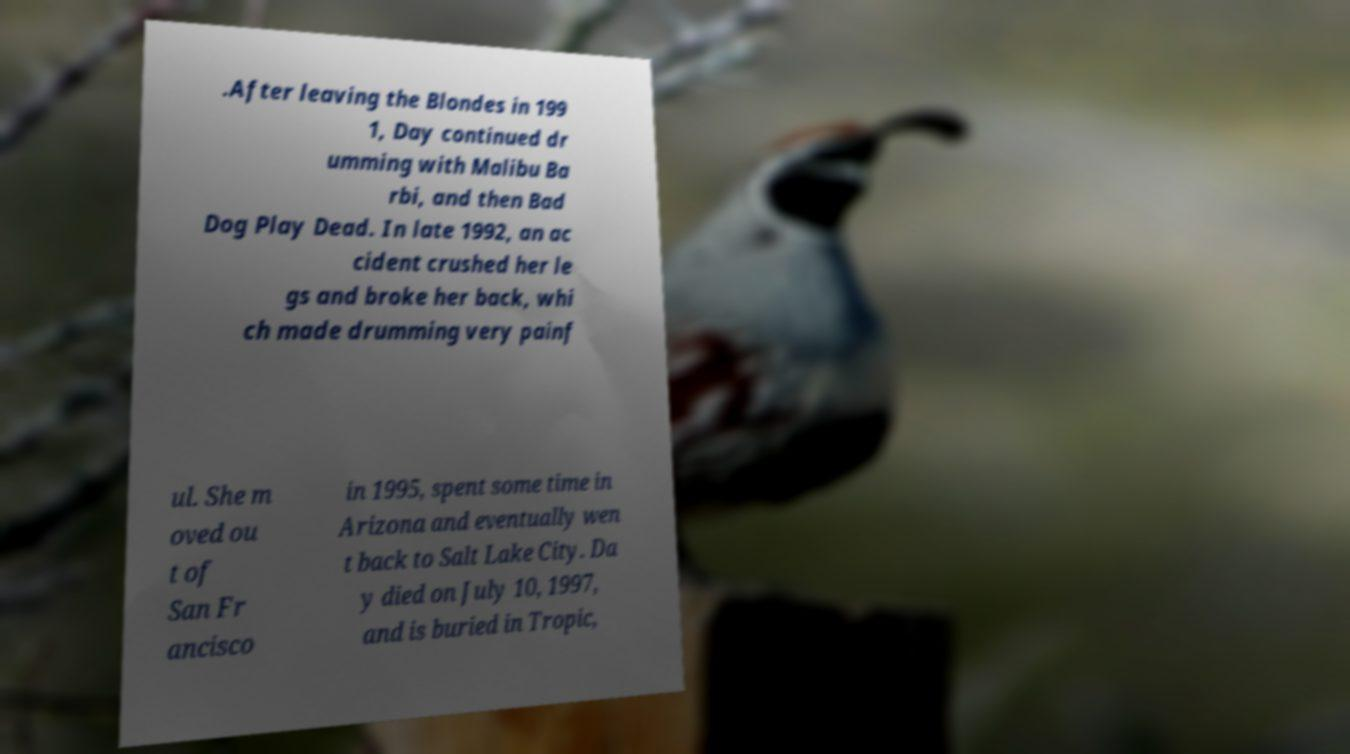Can you read and provide the text displayed in the image?This photo seems to have some interesting text. Can you extract and type it out for me? .After leaving the Blondes in 199 1, Day continued dr umming with Malibu Ba rbi, and then Bad Dog Play Dead. In late 1992, an ac cident crushed her le gs and broke her back, whi ch made drumming very painf ul. She m oved ou t of San Fr ancisco in 1995, spent some time in Arizona and eventually wen t back to Salt Lake City. Da y died on July 10, 1997, and is buried in Tropic, 